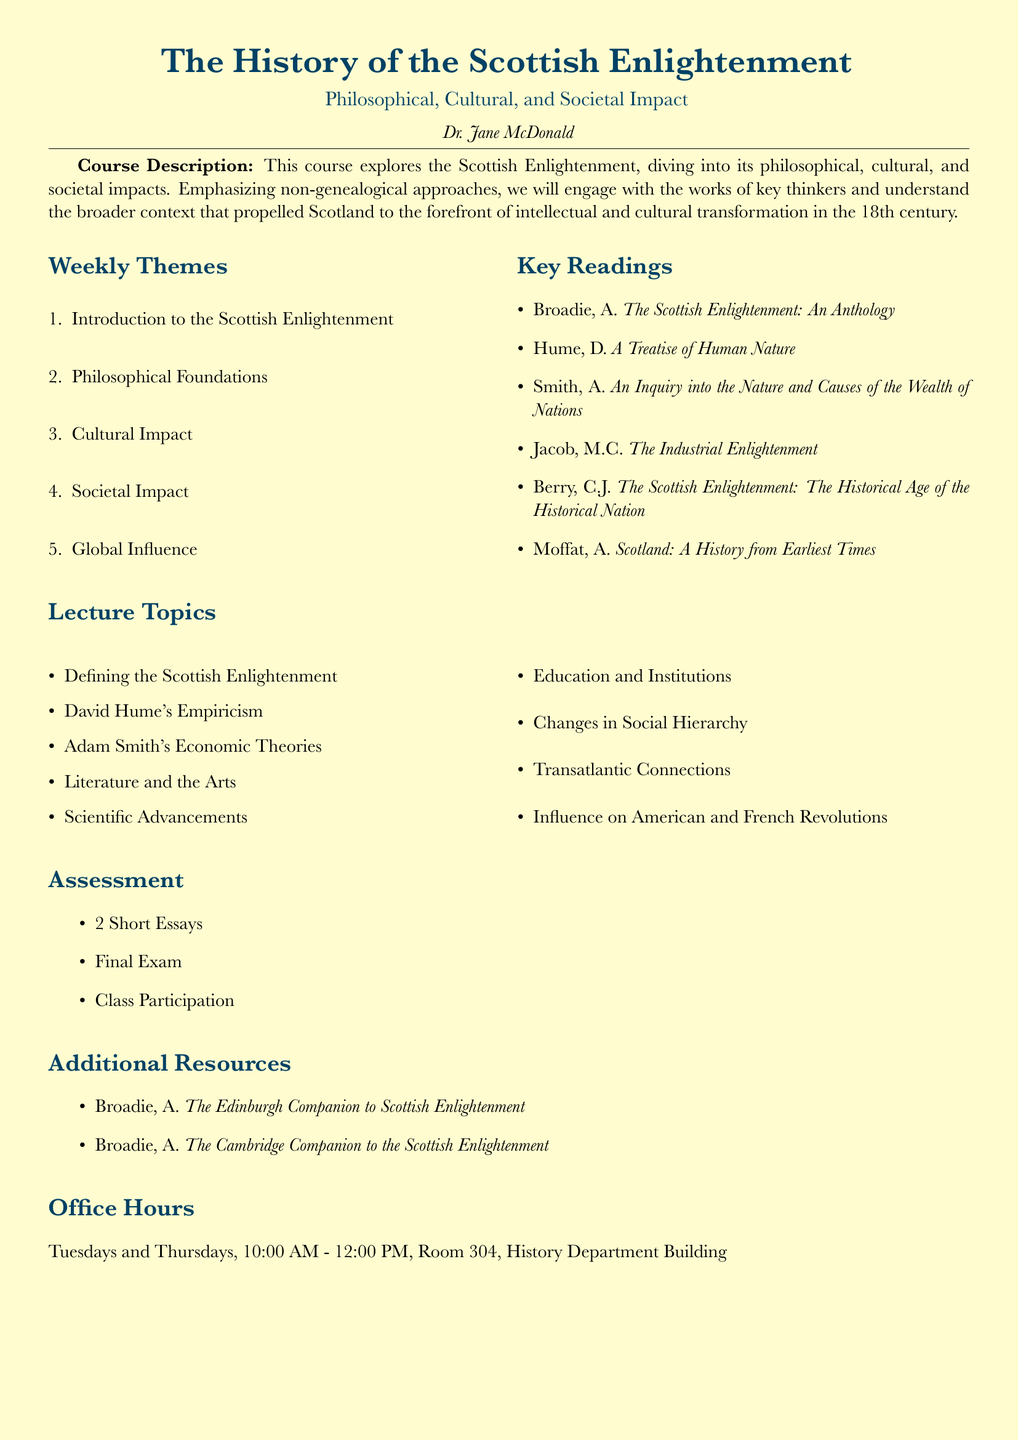What is the name of the course? The course is titled "The History of the Scottish Enlightenment".
Answer: The History of the Scottish Enlightenment Who is the instructor of the course? The instructor listed in the syllabus is Dr. Jane McDonald.
Answer: Dr. Jane McDonald What is a key reading by Adam Smith? Adam Smith's influential work discussed in the syllabus is "An Inquiry into the Nature and Causes of the Wealth of Nations".
Answer: An Inquiry into the Nature and Causes of the Wealth of Nations How many short essays are required for assessment? The syllabus specifies that students must submit 2 Short Essays as part of the assessment.
Answer: 2 Short Essays What topic is related to David Hume? The syllabus includes a lecture topic on "David Hume's Empiricism".
Answer: David Hume's Empiricism When are the office hours for the instructor? The office hours are scheduled for Tuesdays and Thursdays from 10:00 AM to 12:00 PM.
Answer: Tuesdays and Thursdays, 10:00 AM - 12:00 PM What type of impact is emphasized in the course? The course emphasizes the philosophical, cultural, and societal impacts of the Scottish Enlightenment.
Answer: Philosophical, cultural, and societal impacts What are the additional resources listed in the syllabus? The additional resources include works by A. Broadie, specifically "The Edinburgh Companion to Scottish Enlightenment" and "The Cambridge Companion to the Scottish Enlightenment".
Answer: The Edinburgh Companion to Scottish Enlightenment, The Cambridge Companion to the Scottish Enlightenment 